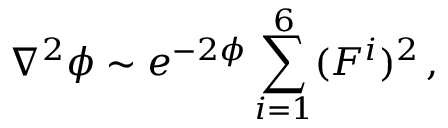<formula> <loc_0><loc_0><loc_500><loc_500>\nabla ^ { 2 } \phi \sim e ^ { - 2 \phi } \sum _ { i = 1 } ^ { 6 } ( F ^ { i } ) ^ { 2 } \, ,</formula> 